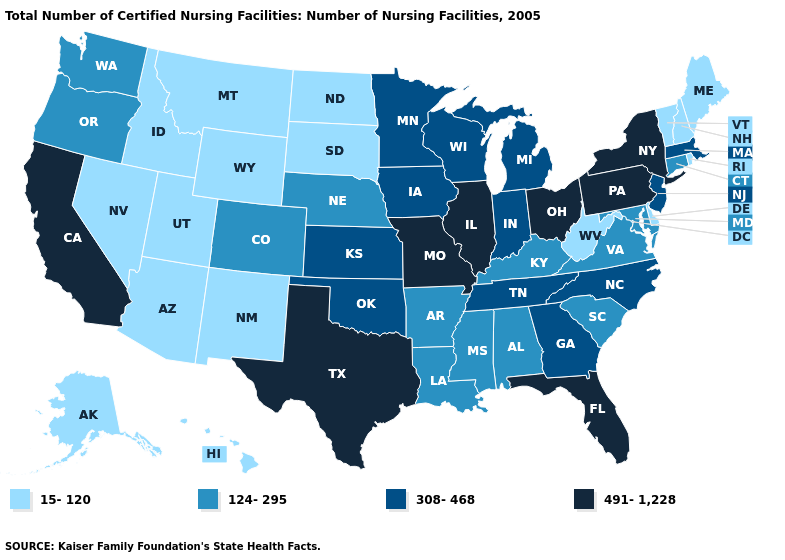What is the value of Arizona?
Answer briefly. 15-120. What is the value of Nevada?
Short answer required. 15-120. Does the first symbol in the legend represent the smallest category?
Keep it brief. Yes. Does South Carolina have a higher value than Wisconsin?
Quick response, please. No. Name the states that have a value in the range 124-295?
Keep it brief. Alabama, Arkansas, Colorado, Connecticut, Kentucky, Louisiana, Maryland, Mississippi, Nebraska, Oregon, South Carolina, Virginia, Washington. Is the legend a continuous bar?
Concise answer only. No. What is the lowest value in states that border Texas?
Keep it brief. 15-120. What is the value of Texas?
Be succinct. 491-1,228. What is the highest value in the USA?
Answer briefly. 491-1,228. Does Kansas have a higher value than Wyoming?
Answer briefly. Yes. What is the highest value in the MidWest ?
Concise answer only. 491-1,228. Name the states that have a value in the range 15-120?
Write a very short answer. Alaska, Arizona, Delaware, Hawaii, Idaho, Maine, Montana, Nevada, New Hampshire, New Mexico, North Dakota, Rhode Island, South Dakota, Utah, Vermont, West Virginia, Wyoming. Name the states that have a value in the range 124-295?
Quick response, please. Alabama, Arkansas, Colorado, Connecticut, Kentucky, Louisiana, Maryland, Mississippi, Nebraska, Oregon, South Carolina, Virginia, Washington. Is the legend a continuous bar?
Keep it brief. No. Does North Carolina have the same value as Alaska?
Concise answer only. No. 